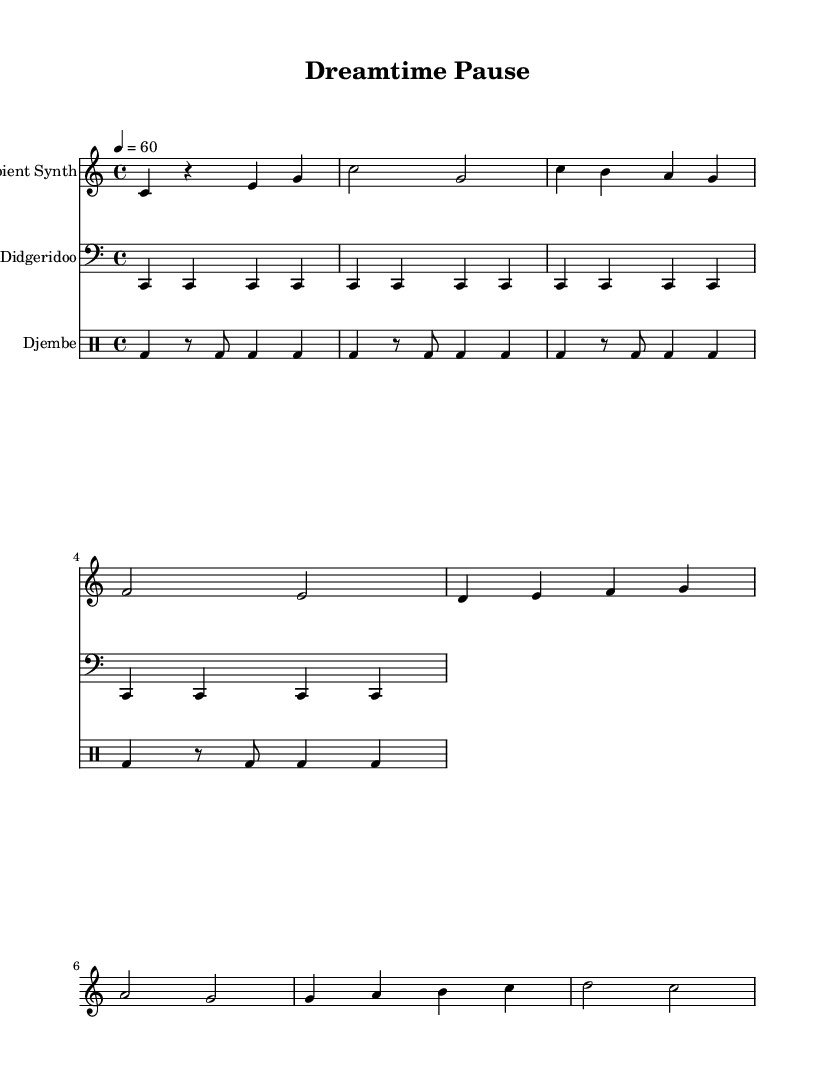What is the key signature of this music? The key signature is identified in the global settings of the score, which indicates C major. C major has no sharps or flats in its signature.
Answer: C major What is the time signature of this piece? The time signature is specified in the global settings as 4/4. This means there are four beats per measure, each represented by a quarter note.
Answer: 4/4 What is the tempo indicated in the music? The tempo is indicated in the global settings, which shows a tempo marking of 4 = 60. This indicates that there are 60 beats per minute.
Answer: 60 How many measures are repeated in the didgeridoo part? The didgeridoo has a repeat instruction that indicates its phrases are repeated four times in the score. Each phrase in the didgeridoo consists of four quarter notes.
Answer: 4 What instruments are featured in this score? The instruments are listed in the score section with respective staff names. The three instruments are "Ambient Synth," "Didgeridoo," and "Djembe."
Answer: Ambient Synth, Didgeridoo, Djembe What rhythmic pattern does the djembe follow? The djembe part consists of a specific pattern that includes bass drum hits combined with rests and eighth notes, showing a repetitive and percussive foundation.
Answer: Bass drum with rests and eighth notes What type of music genre does this composition represent? The composition features elements from World Music, specifically Australian Aboriginal music through the use of the didgeridoo, layered with contemporary beats suitable for mindfulness sessions.
Answer: World Music 